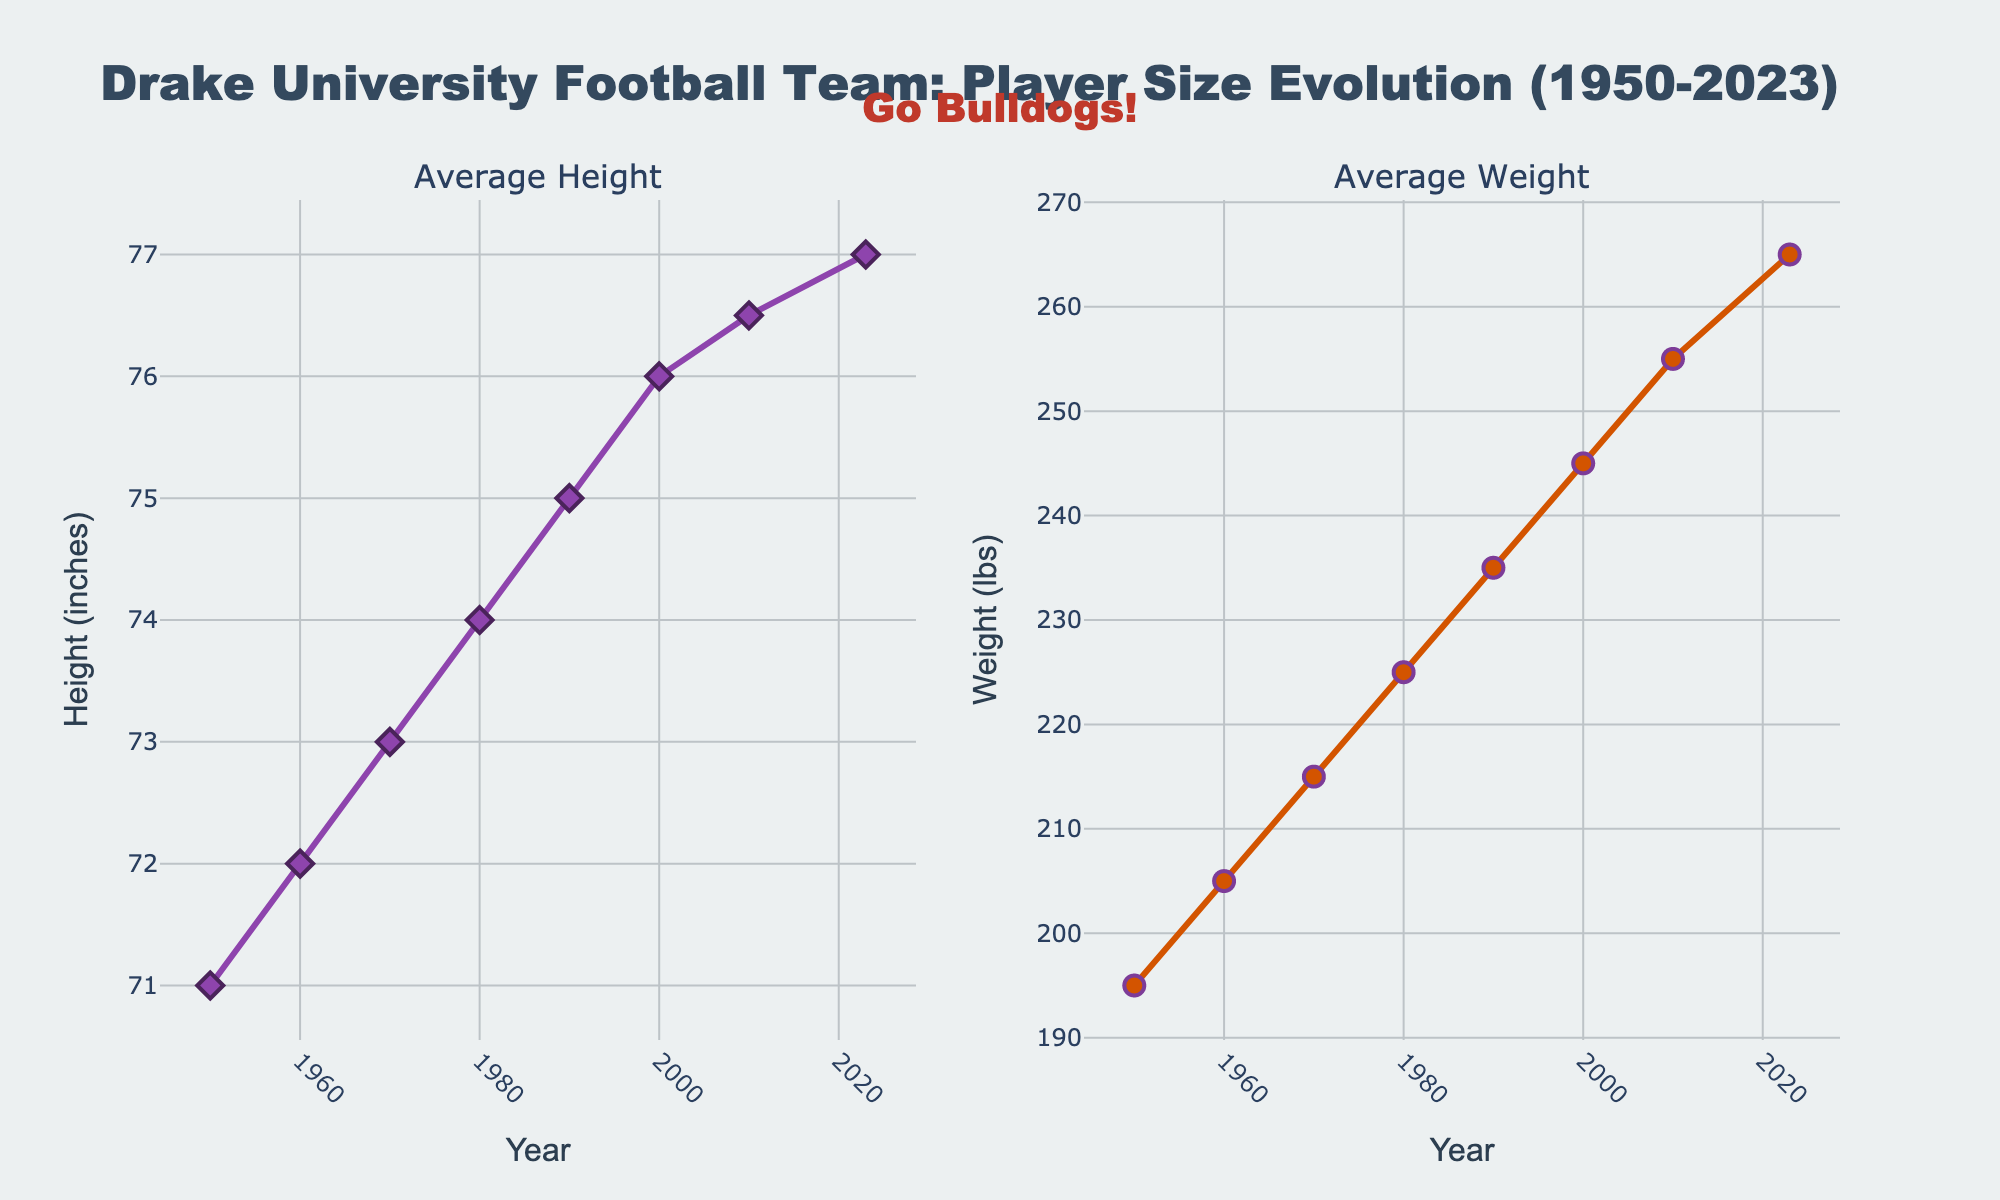What is the title of the plot? The title of the plot is written at the top of the figure, indicating the subject of the horizontal subplots.
Answer: "Global Temperature Anomalies by Continent (1920-2020)" What does the x-axis represent? The x-axis, labeled at the bottom of the figure, represents the years from 1920 to 2020.
Answer: Years Which continent has the highest temperature anomaly in 2020? By looking at the last data points on each subplot for the year 2020, Europe shows the highest temperature anomaly.
Answer: Europe What is the temperature anomaly for Africa in 1940? In the subplot for Africa, you can see the data point corresponding to the year 1940. The temperature anomaly value is -0.09°C.
Answer: -0.09°C Which continent experienced the largest increase in temperature anomaly from 1920 to 2020? Calculate the difference between the temperature anomalies in 1920 and 2020 for each continent: 
North America: 1.68 - (-0.27) = 1.95
Europe: 1.94 - (-0.21) = 2.15
Asia: 1.76 - (-0.18) = 1.94
Africa: 1.52 - (-0.28) = 1.80
South America: 1.39 - (-0.23) = 1.62
Australia: 1.47 - (-0.39) = 1.86
Europe has the largest increase.
Answer: Europe Which continent had the lowest temperature anomaly in 1920? Look at the first data point on each subplot for the year 1920. Australia has the lowest temperature anomaly at -0.39°C.
Answer: Australia By how much did the temperature anomaly for North America increase between 2000 and 2020? Find the difference between the temperature anomalies for North America in 2020 and 2000: 1.68 - 0.84 = 0.84°C.
Answer: 0.84°C What overall trend do you observe in global temperature anomalies across all continents? All subplots show a general upward trend in temperature anomalies from 1920 to 2020, indicating a warming pattern.
Answer: Warming trend 